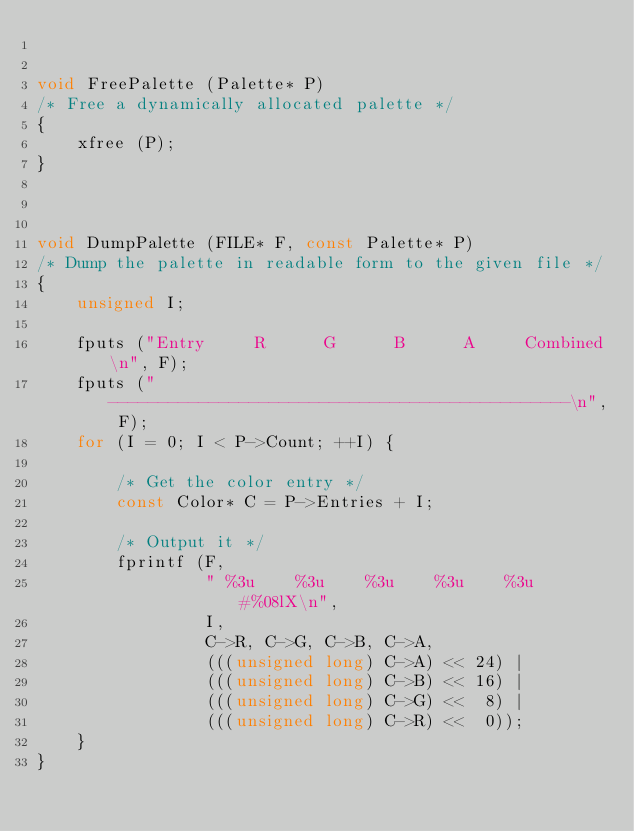<code> <loc_0><loc_0><loc_500><loc_500><_C_>

void FreePalette (Palette* P)
/* Free a dynamically allocated palette */
{
    xfree (P);
}



void DumpPalette (FILE* F, const Palette* P)
/* Dump the palette in readable form to the given file */
{
    unsigned I;

    fputs ("Entry     R      G      B      A     Combined\n", F);
    fputs ("----------------------------------------------\n", F);
    for (I = 0; I < P->Count; ++I) {

        /* Get the color entry */
        const Color* C = P->Entries + I;

        /* Output it */
        fprintf (F,
                 " %3u    %3u    %3u    %3u    %3u    #%08lX\n",
                 I,
                 C->R, C->G, C->B, C->A,
                 (((unsigned long) C->A) << 24) |
                 (((unsigned long) C->B) << 16) |
                 (((unsigned long) C->G) <<  8) |
                 (((unsigned long) C->R) <<  0));
    }
}
</code> 